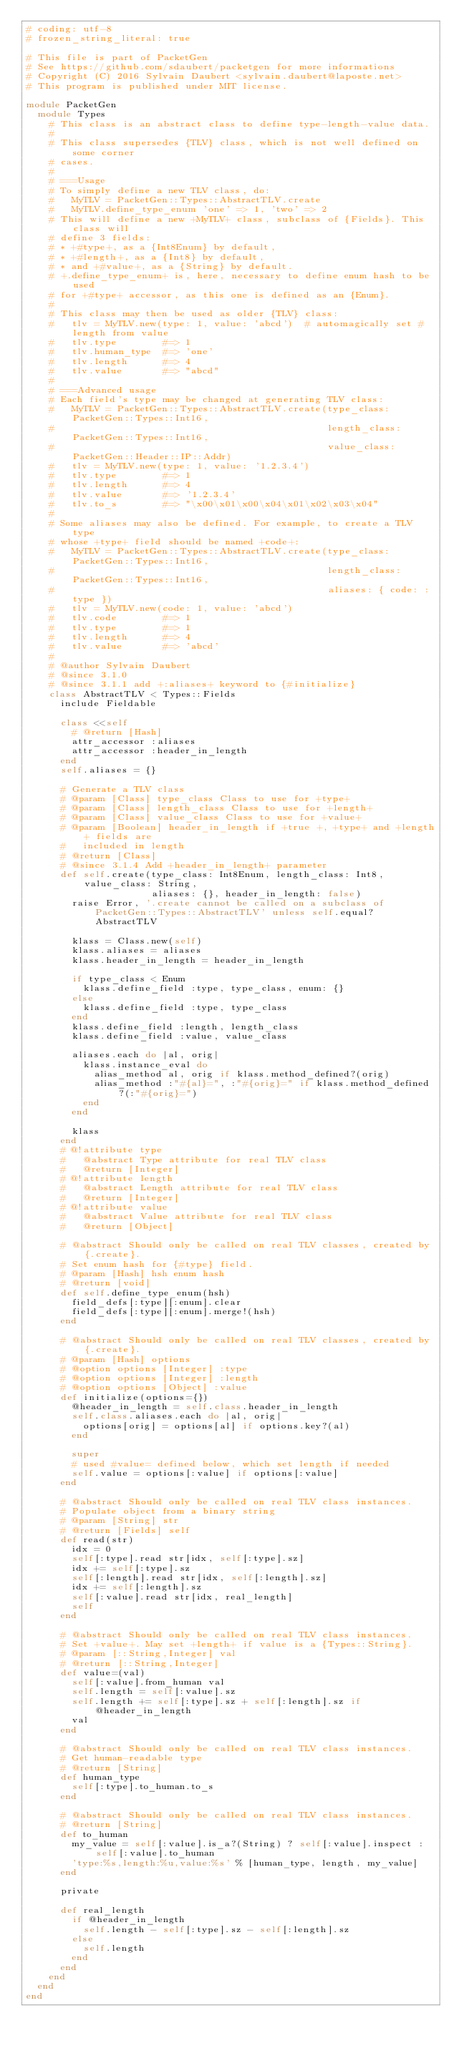Convert code to text. <code><loc_0><loc_0><loc_500><loc_500><_Ruby_># coding: utf-8
# frozen_string_literal: true

# This file is part of PacketGen
# See https://github.com/sdaubert/packetgen for more informations
# Copyright (C) 2016 Sylvain Daubert <sylvain.daubert@laposte.net>
# This program is published under MIT license.

module PacketGen
  module Types
    # This class is an abstract class to define type-length-value data.
    #
    # This class supersedes {TLV} class, which is not well defined on some corner
    # cases.
    #
    # ===Usage
    # To simply define a new TLV class, do:
    #   MyTLV = PacketGen::Types::AbstractTLV.create
    #   MyTLV.define_type_enum 'one' => 1, 'two' => 2
    # This will define a new +MyTLV+ class, subclass of {Fields}. This class will
    # define 3 fields:
    # * +#type+, as a {Int8Enum} by default,
    # * +#length+, as a {Int8} by default,
    # * and +#value+, as a {String} by default.
    # +.define_type_enum+ is, here, necessary to define enum hash to be used
    # for +#type+ accessor, as this one is defined as an {Enum}.
    #
    # This class may then be used as older {TLV} class:
    #   tlv = MyTLV.new(type: 1, value: 'abcd')  # automagically set #length from value
    #   tlv.type        #=> 1
    #   tlv.human_type  #=> 'one'
    #   tlv.length      #=> 4
    #   tlv.value       #=> "abcd"
    #
    # ===Advanced usage
    # Each field's type may be changed at generating TLV class:
    #   MyTLV = PacketGen::Types::AbstractTLV.create(type_class: PacketGen::Types::Int16,
    #                                                length_class: PacketGen::Types::Int16,
    #                                                value_class: PacketGen::Header::IP::Addr)
    #   tlv = MyTLV.new(type: 1, value: '1.2.3.4')
    #   tlv.type        #=> 1
    #   tlv.length      #=> 4
    #   tlv.value       #=> '1.2.3.4'
    #   tlv.to_s        #=> "\x00\x01\x00\x04\x01\x02\x03\x04"
    #
    # Some aliases may also be defined. For example, to create a TLV type
    # whose +type+ field should be named +code+:
    #   MyTLV = PacketGen::Types::AbstractTLV.create(type_class: PacketGen::Types::Int16,
    #                                                length_class: PacketGen::Types::Int16,
    #                                                aliases: { code: :type })
    #   tlv = MyTLV.new(code: 1, value: 'abcd')
    #   tlv.code        #=> 1
    #   tlv.type        #=> 1
    #   tlv.length      #=> 4
    #   tlv.value       #=> 'abcd'
    #
    # @author Sylvain Daubert
    # @since 3.1.0
    # @since 3.1.1 add +:aliases+ keyword to {#initialize}
    class AbstractTLV < Types::Fields
      include Fieldable

      class <<self
        # @return [Hash]
        attr_accessor :aliases
        attr_accessor :header_in_length
      end
      self.aliases = {}

      # Generate a TLV class
      # @param [Class] type_class Class to use for +type+
      # @param [Class] length_class Class to use for +length+
      # @param [Class] value_class Class to use for +value+
      # @param [Boolean] header_in_length if +true +, +type+ and +length+ fields are
      #   included in length
      # @return [Class]
      # @since 3.1.4 Add +header_in_length+ parameter
      def self.create(type_class: Int8Enum, length_class: Int8, value_class: String,
                      aliases: {}, header_in_length: false)
        raise Error, '.create cannot be called on a subclass of PacketGen::Types::AbstractTLV' unless self.equal? AbstractTLV

        klass = Class.new(self)
        klass.aliases = aliases
        klass.header_in_length = header_in_length

        if type_class < Enum
          klass.define_field :type, type_class, enum: {}
        else
          klass.define_field :type, type_class
        end
        klass.define_field :length, length_class
        klass.define_field :value, value_class

        aliases.each do |al, orig|
          klass.instance_eval do
            alias_method al, orig if klass.method_defined?(orig)
            alias_method :"#{al}=", :"#{orig}=" if klass.method_defined?(:"#{orig}=")
          end
        end

        klass
      end
      # @!attribute type
      #   @abstract Type attribute for real TLV class
      #   @return [Integer]
      # @!attribute length
      #   @abstract Length attribute for real TLV class
      #   @return [Integer]
      # @!attribute value
      #   @abstract Value attribute for real TLV class
      #   @return [Object]

      # @abstract Should only be called on real TLV classes, created by {.create}.
      # Set enum hash for {#type} field.
      # @param [Hash] hsh enum hash
      # @return [void]
      def self.define_type_enum(hsh)
        field_defs[:type][:enum].clear
        field_defs[:type][:enum].merge!(hsh)
      end

      # @abstract Should only be called on real TLV classes, created by {.create}.
      # @param [Hash] options
      # @option options [Integer] :type
      # @option options [Integer] :length
      # @option options [Object] :value
      def initialize(options={})
        @header_in_length = self.class.header_in_length
        self.class.aliases.each do |al, orig|
          options[orig] = options[al] if options.key?(al)
        end

        super
        # used #value= defined below, which set length if needed
        self.value = options[:value] if options[:value]
      end

      # @abstract Should only be called on real TLV class instances.
      # Populate object from a binary string
      # @param [String] str
      # @return [Fields] self
      def read(str)
        idx = 0
        self[:type].read str[idx, self[:type].sz]
        idx += self[:type].sz
        self[:length].read str[idx, self[:length].sz]
        idx += self[:length].sz
        self[:value].read str[idx, real_length]
        self
      end

      # @abstract Should only be called on real TLV class instances.
      # Set +value+. May set +length+ if value is a {Types::String}.
      # @param [::String,Integer] val
      # @return [::String,Integer]
      def value=(val)
        self[:value].from_human val
        self.length = self[:value].sz
        self.length += self[:type].sz + self[:length].sz if @header_in_length
        val
      end

      # @abstract Should only be called on real TLV class instances.
      # Get human-readable type
      # @return [String]
      def human_type
        self[:type].to_human.to_s
      end

      # @abstract Should only be called on real TLV class instances.
      # @return [String]
      def to_human
        my_value = self[:value].is_a?(String) ? self[:value].inspect : self[:value].to_human
        'type:%s,length:%u,value:%s' % [human_type, length, my_value]
      end

      private

      def real_length
        if @header_in_length
          self.length - self[:type].sz - self[:length].sz
        else
          self.length
        end
      end
    end
  end
end
</code> 